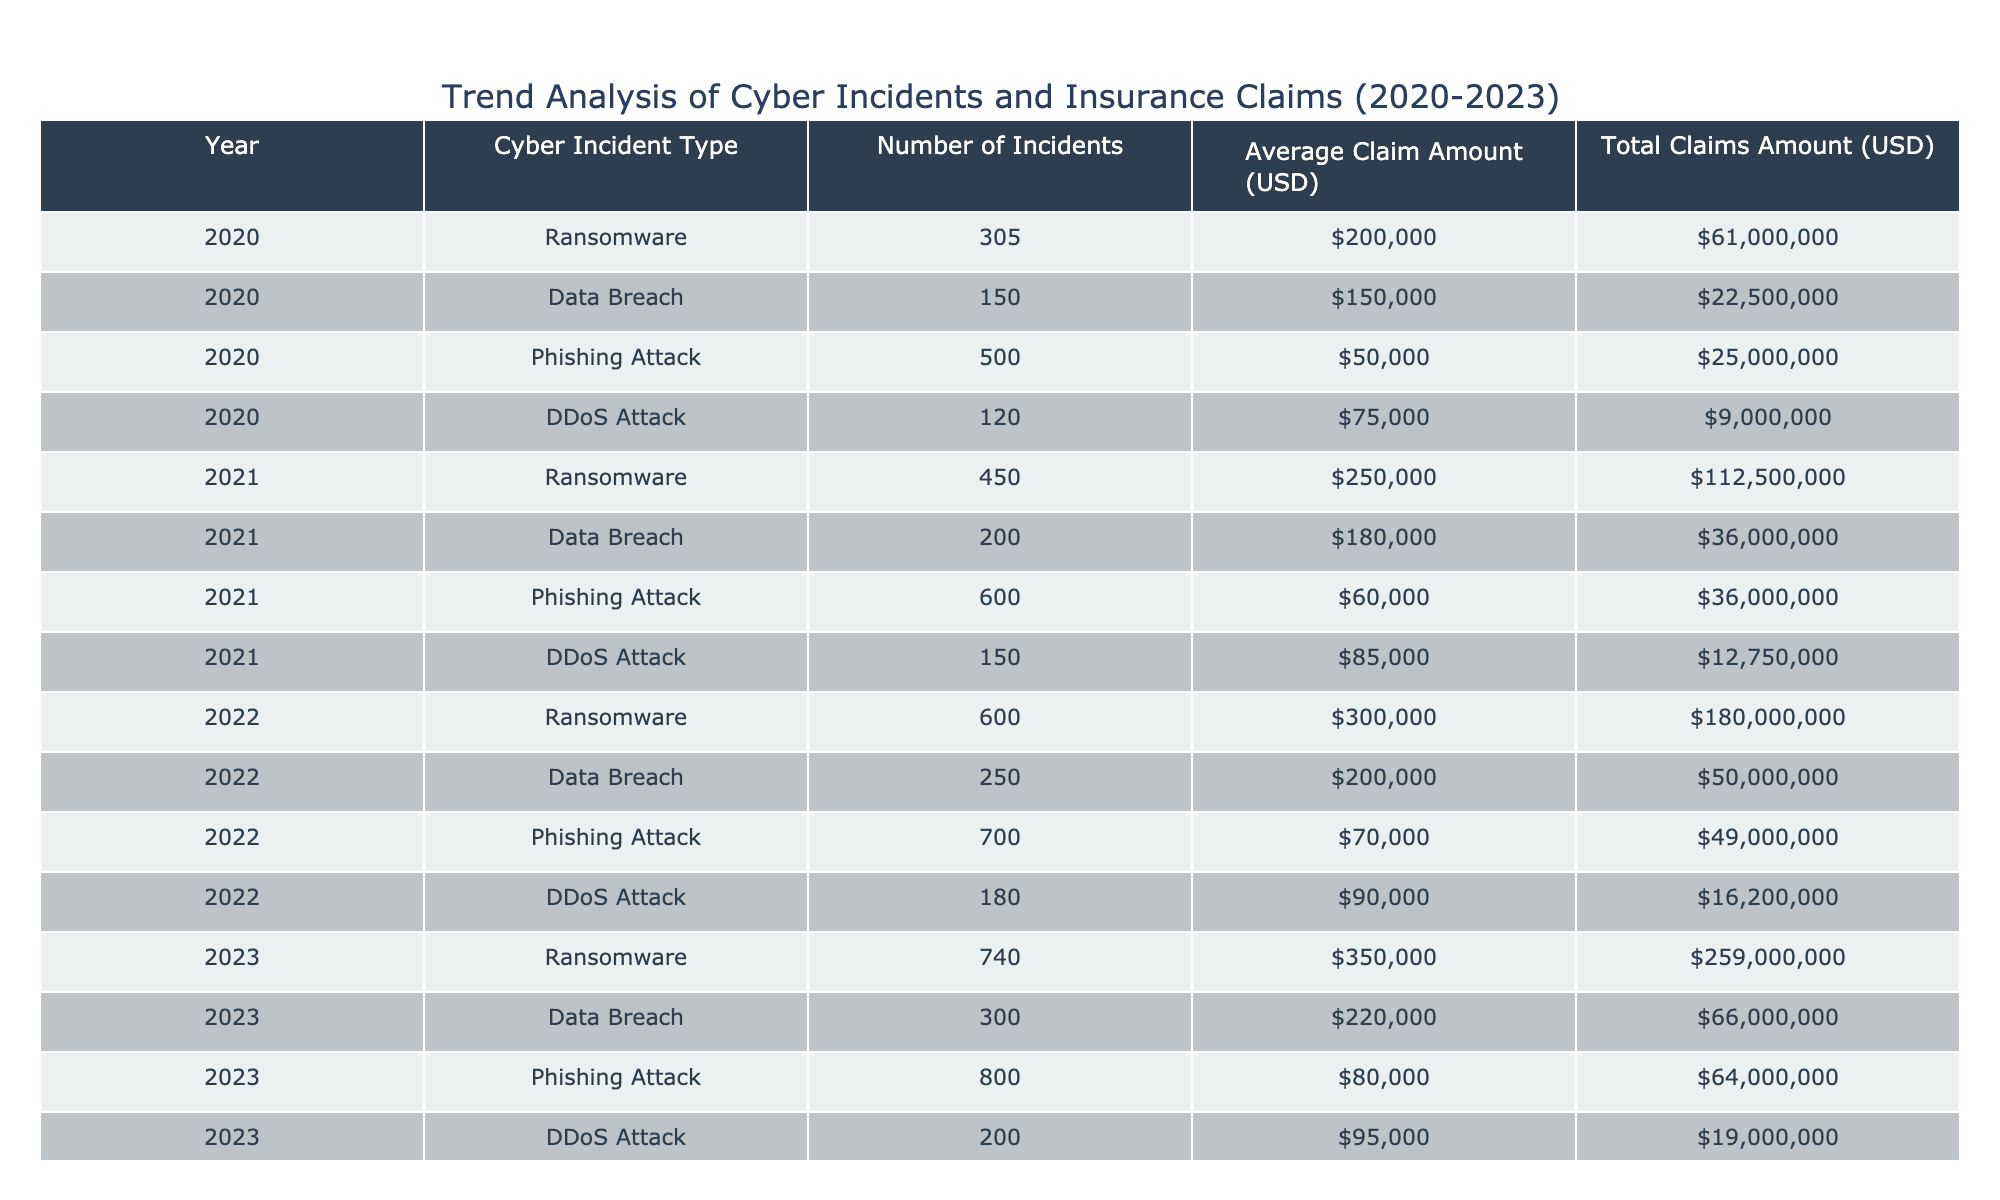What was the total number of ransomware incidents reported in 2022? According to the table, the number of ransomware incidents in 2022 is listed under the "Number of Incidents" column for that year, which shows 600 incidents.
Answer: 600 What is the average claim amount for phishing attacks in 2023? The average claim amount for phishing attacks in 2023 can be directly found in the "Average Claim Amount (USD)" column for that year, which states it is 80,000 USD.
Answer: 80,000 How much did ransomware claims total across all years? To find the total ransomware claims, we sum the "Total Claims Amount (USD)" for ransomware across all years: 61,000,000 (2020) + 112,500,000 (2021) + 180,000,000 (2022) + 259,000,000 (2023) = 612,500,000 USD.
Answer: 612,500,000 Were there more phishing attack incidents in 2023 compared to 2021? By comparing the "Number of Incidents" column, there were 800 phishing attack incidents in 2023 and 600 in 2021, indicating that there were indeed more incidents in 2023.
Answer: Yes What was the percentage increase in the average claim amount for ransomware from 2020 to 2023? The average claim amount for ransomware in 2020 was 200,000 USD and in 2023 it was 350,000 USD. The increase is (350,000 - 200,000) / 200,000 * 100 = 75%.
Answer: 75% How many total DDoS attack incidents were reported from 2020 to 2023? The total number of DDoS attack incidents can be calculated by adding the "Number of Incidents" for each year: 120 (2020) + 150 (2021) + 180 (2022) + 200 (2023) = 650 incidents.
Answer: 650 Is the total claims amount for data breaches greater than that for DDoS attacks in 2022? For 2022, the total claims amount for data breaches is 50,000,000 USD, and for DDoS attacks, it is 16,200,000 USD. Since 50,000,000 is greater than 16,200,000, the answer is yes.
Answer: Yes What is the average number of incidents per year for phishing attacks from 2020 to 2023? To find the average, we add the number of incidents for phishing from each year: 500 (2020) + 600 (2021) + 700 (2022) + 800 (2023) = 2600 incidents, then divide by 4 (years) to get an average of 650 incidents per year.
Answer: 650 